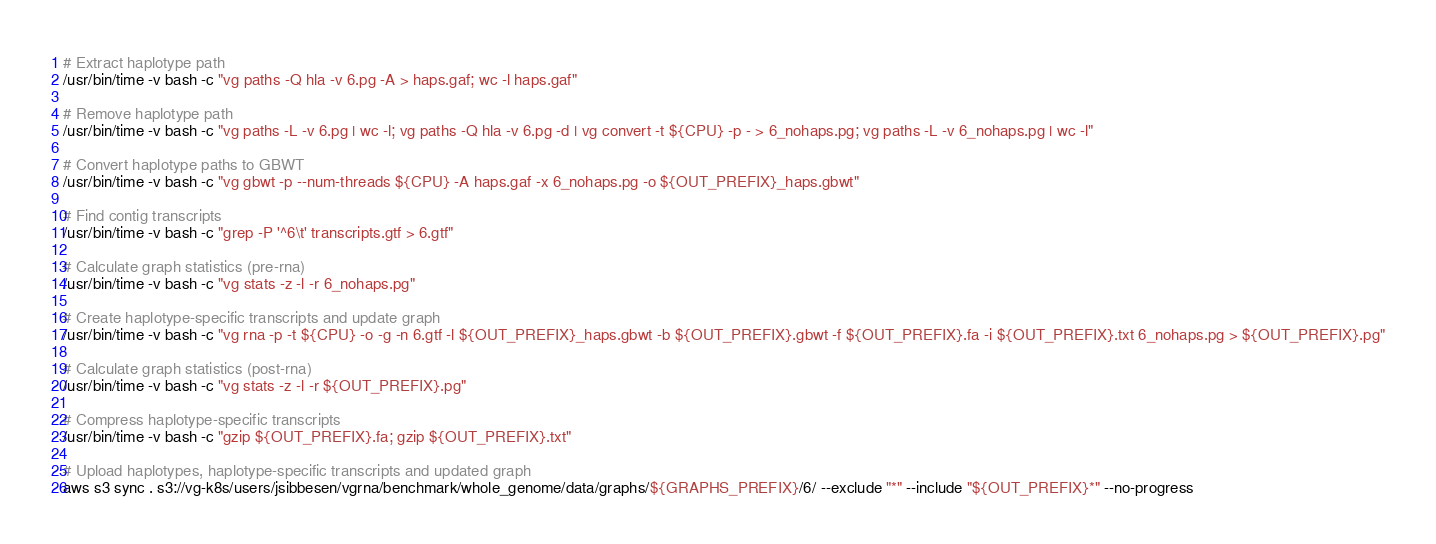<code> <loc_0><loc_0><loc_500><loc_500><_Bash_># Extract haplotype path
/usr/bin/time -v bash -c "vg paths -Q hla -v 6.pg -A > haps.gaf; wc -l haps.gaf"

# Remove haplotype path
/usr/bin/time -v bash -c "vg paths -L -v 6.pg | wc -l; vg paths -Q hla -v 6.pg -d | vg convert -t ${CPU} -p - > 6_nohaps.pg; vg paths -L -v 6_nohaps.pg | wc -l"

# Convert haplotype paths to GBWT
/usr/bin/time -v bash -c "vg gbwt -p --num-threads ${CPU} -A haps.gaf -x 6_nohaps.pg -o ${OUT_PREFIX}_haps.gbwt"

# Find contig transcripts
/usr/bin/time -v bash -c "grep -P '^6\t' transcripts.gtf > 6.gtf"

# Calculate graph statistics (pre-rna) 
/usr/bin/time -v bash -c "vg stats -z -l -r 6_nohaps.pg"

# Create haplotype-specific transcripts and update graph
/usr/bin/time -v bash -c "vg rna -p -t ${CPU} -o -g -n 6.gtf -l ${OUT_PREFIX}_haps.gbwt -b ${OUT_PREFIX}.gbwt -f ${OUT_PREFIX}.fa -i ${OUT_PREFIX}.txt 6_nohaps.pg > ${OUT_PREFIX}.pg"

# Calculate graph statistics (post-rna) 
/usr/bin/time -v bash -c "vg stats -z -l -r ${OUT_PREFIX}.pg"

# Compress haplotype-specific transcripts
/usr/bin/time -v bash -c "gzip ${OUT_PREFIX}.fa; gzip ${OUT_PREFIX}.txt"

# Upload haplotypes, haplotype-specific transcripts and updated graph
aws s3 sync . s3://vg-k8s/users/jsibbesen/vgrna/benchmark/whole_genome/data/graphs/${GRAPHS_PREFIX}/6/ --exclude "*" --include "${OUT_PREFIX}*" --no-progress
</code> 